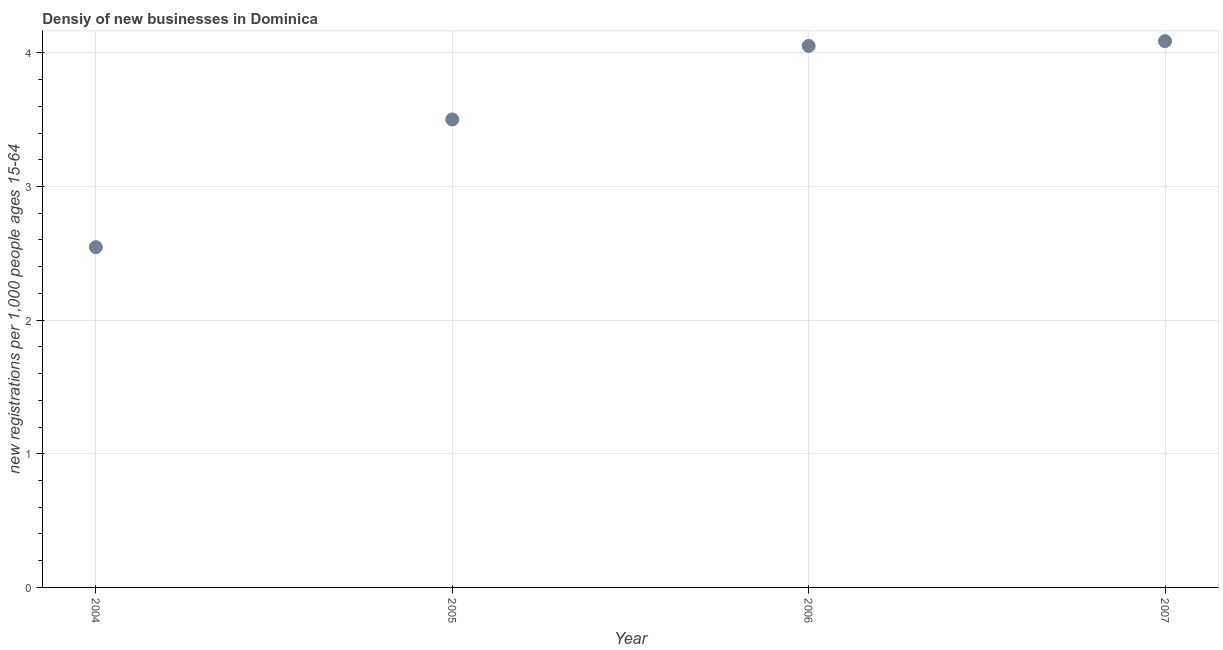What is the density of new business in 2006?
Provide a succinct answer. 4.05. Across all years, what is the maximum density of new business?
Provide a succinct answer. 4.09. Across all years, what is the minimum density of new business?
Ensure brevity in your answer.  2.55. In which year was the density of new business maximum?
Offer a very short reply. 2007. What is the sum of the density of new business?
Make the answer very short. 14.19. What is the difference between the density of new business in 2004 and 2006?
Your response must be concise. -1.51. What is the average density of new business per year?
Offer a terse response. 3.55. What is the median density of new business?
Give a very brief answer. 3.78. In how many years, is the density of new business greater than 1 ?
Offer a very short reply. 4. What is the ratio of the density of new business in 2004 to that in 2007?
Give a very brief answer. 0.62. What is the difference between the highest and the second highest density of new business?
Offer a terse response. 0.04. What is the difference between the highest and the lowest density of new business?
Your response must be concise. 1.54. How many dotlines are there?
Offer a terse response. 1. How many years are there in the graph?
Keep it short and to the point. 4. Does the graph contain any zero values?
Your answer should be compact. No. What is the title of the graph?
Ensure brevity in your answer.  Densiy of new businesses in Dominica. What is the label or title of the X-axis?
Provide a short and direct response. Year. What is the label or title of the Y-axis?
Your answer should be compact. New registrations per 1,0 people ages 15-64. What is the new registrations per 1,000 people ages 15-64 in 2004?
Offer a terse response. 2.55. What is the new registrations per 1,000 people ages 15-64 in 2005?
Provide a succinct answer. 3.5. What is the new registrations per 1,000 people ages 15-64 in 2006?
Your answer should be compact. 4.05. What is the new registrations per 1,000 people ages 15-64 in 2007?
Your answer should be compact. 4.09. What is the difference between the new registrations per 1,000 people ages 15-64 in 2004 and 2005?
Make the answer very short. -0.96. What is the difference between the new registrations per 1,000 people ages 15-64 in 2004 and 2006?
Your answer should be compact. -1.51. What is the difference between the new registrations per 1,000 people ages 15-64 in 2004 and 2007?
Provide a short and direct response. -1.54. What is the difference between the new registrations per 1,000 people ages 15-64 in 2005 and 2006?
Make the answer very short. -0.55. What is the difference between the new registrations per 1,000 people ages 15-64 in 2005 and 2007?
Ensure brevity in your answer.  -0.59. What is the difference between the new registrations per 1,000 people ages 15-64 in 2006 and 2007?
Ensure brevity in your answer.  -0.04. What is the ratio of the new registrations per 1,000 people ages 15-64 in 2004 to that in 2005?
Offer a very short reply. 0.73. What is the ratio of the new registrations per 1,000 people ages 15-64 in 2004 to that in 2006?
Offer a very short reply. 0.63. What is the ratio of the new registrations per 1,000 people ages 15-64 in 2004 to that in 2007?
Offer a terse response. 0.62. What is the ratio of the new registrations per 1,000 people ages 15-64 in 2005 to that in 2006?
Keep it short and to the point. 0.86. What is the ratio of the new registrations per 1,000 people ages 15-64 in 2005 to that in 2007?
Your answer should be very brief. 0.86. What is the ratio of the new registrations per 1,000 people ages 15-64 in 2006 to that in 2007?
Your response must be concise. 0.99. 